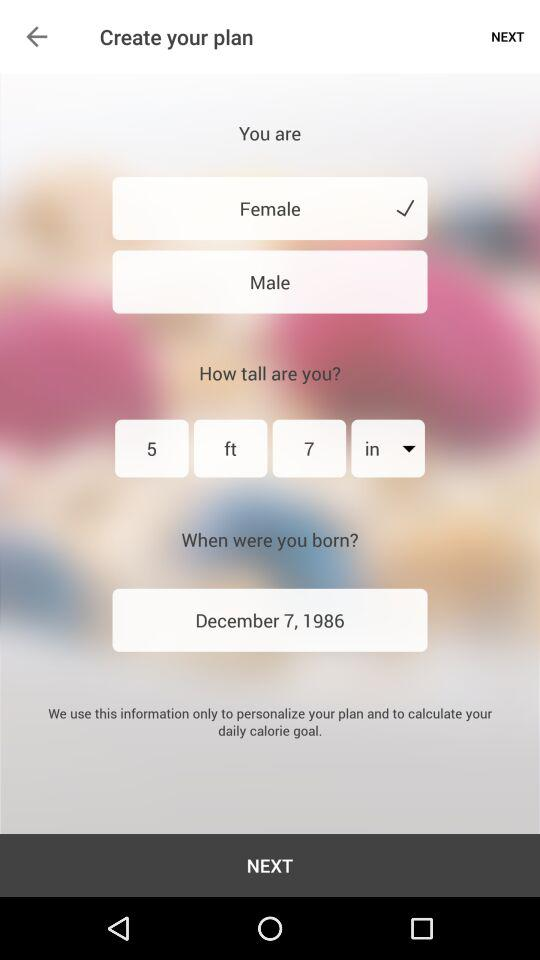What is the selected gender? The selected gender is "Female". 